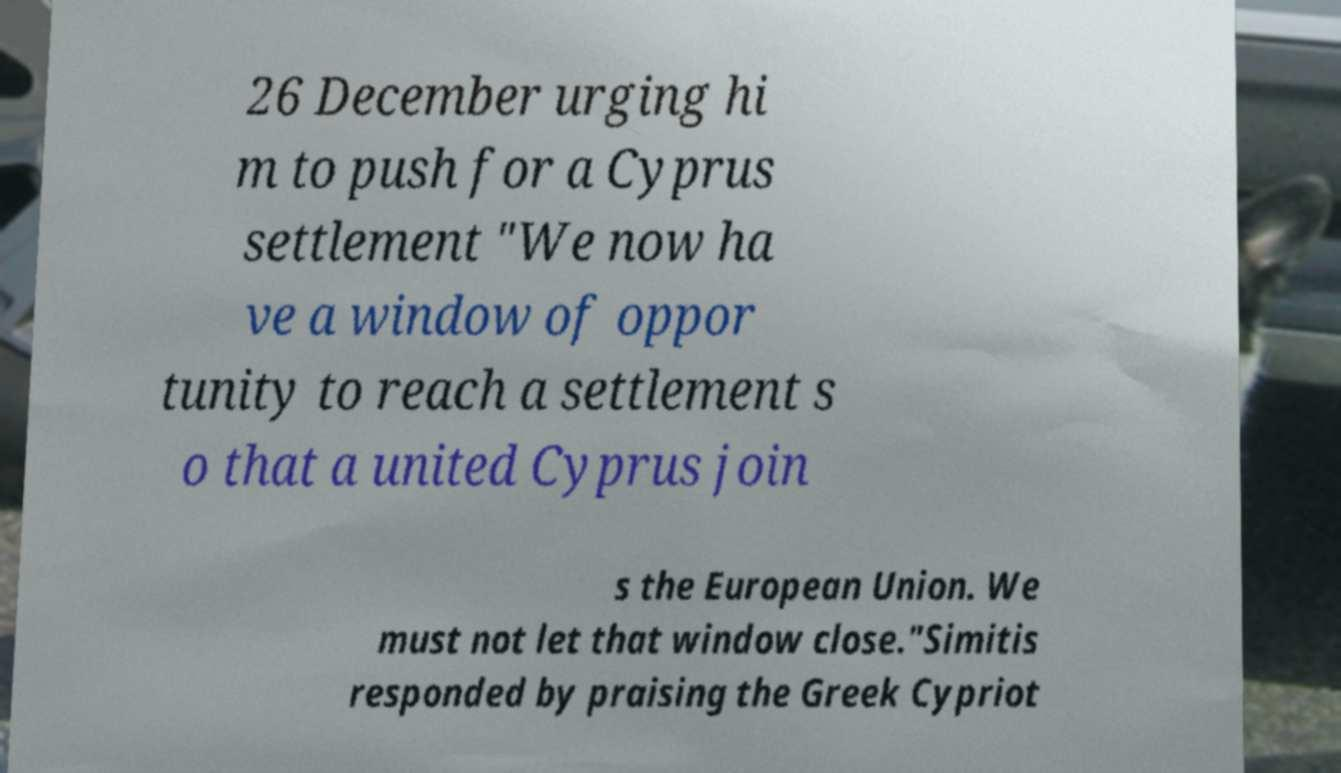Can you read and provide the text displayed in the image?This photo seems to have some interesting text. Can you extract and type it out for me? 26 December urging hi m to push for a Cyprus settlement "We now ha ve a window of oppor tunity to reach a settlement s o that a united Cyprus join s the European Union. We must not let that window close."Simitis responded by praising the Greek Cypriot 